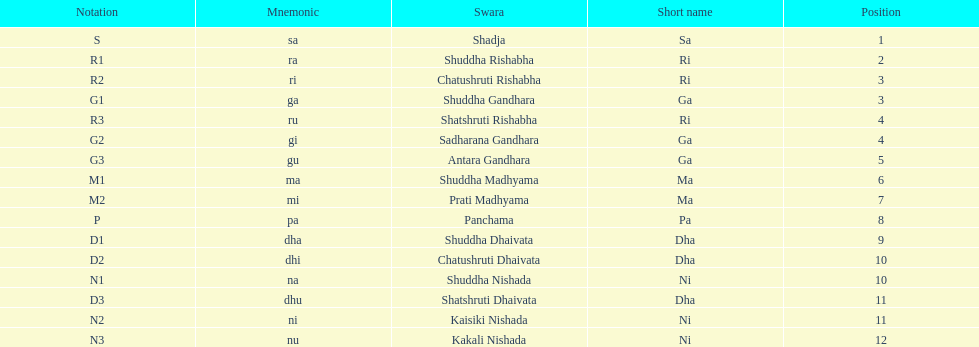What swara is above shatshruti dhaivata? Shuddha Nishada. 